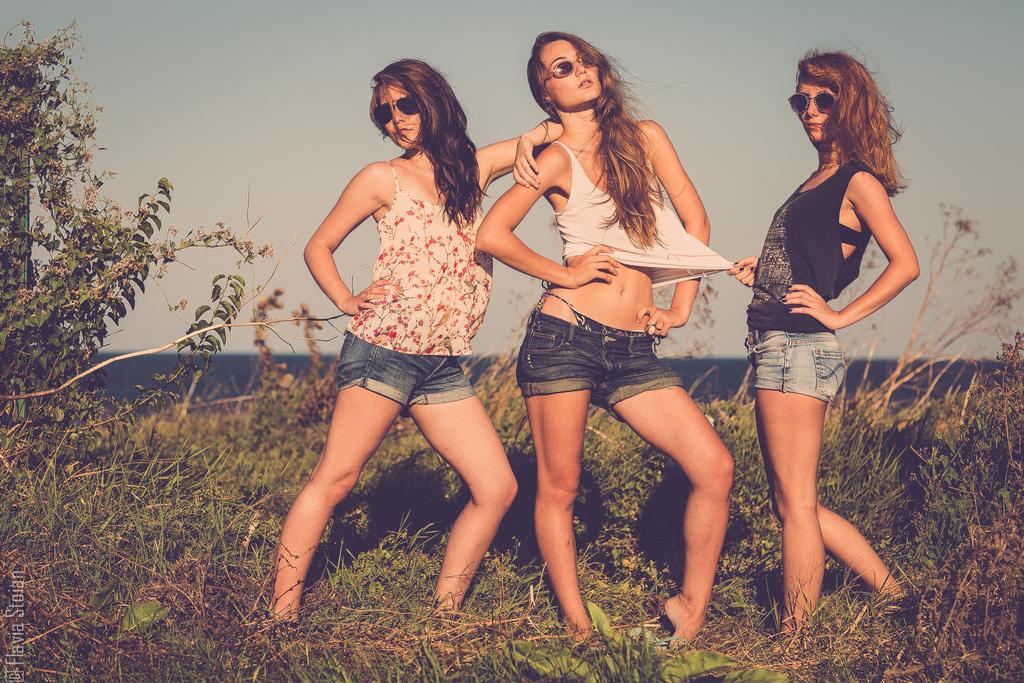How many women are present in the image? There are three women in the image. What are the women wearing in the image? The women are wearing spectacles in the image. What else can be seen in the image besides the women? There are plants in the image. What type of alley can be seen in the background of the image? There is no alley present in the image; it only features three women wearing spectacles and plants. 